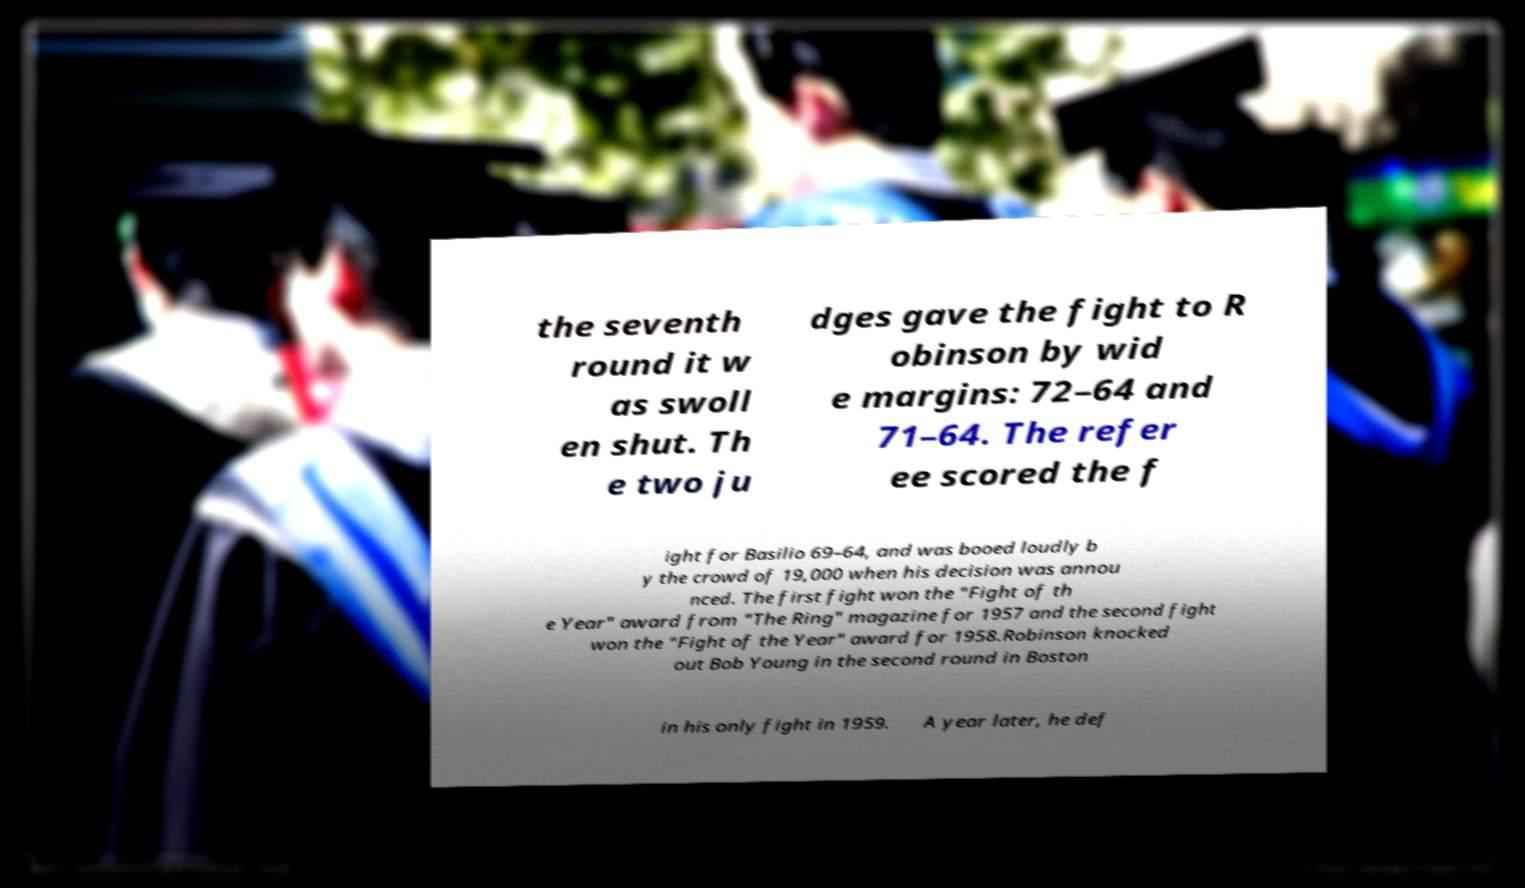Could you extract and type out the text from this image? the seventh round it w as swoll en shut. Th e two ju dges gave the fight to R obinson by wid e margins: 72–64 and 71–64. The refer ee scored the f ight for Basilio 69–64, and was booed loudly b y the crowd of 19,000 when his decision was annou nced. The first fight won the "Fight of th e Year" award from "The Ring" magazine for 1957 and the second fight won the "Fight of the Year" award for 1958.Robinson knocked out Bob Young in the second round in Boston in his only fight in 1959. A year later, he def 